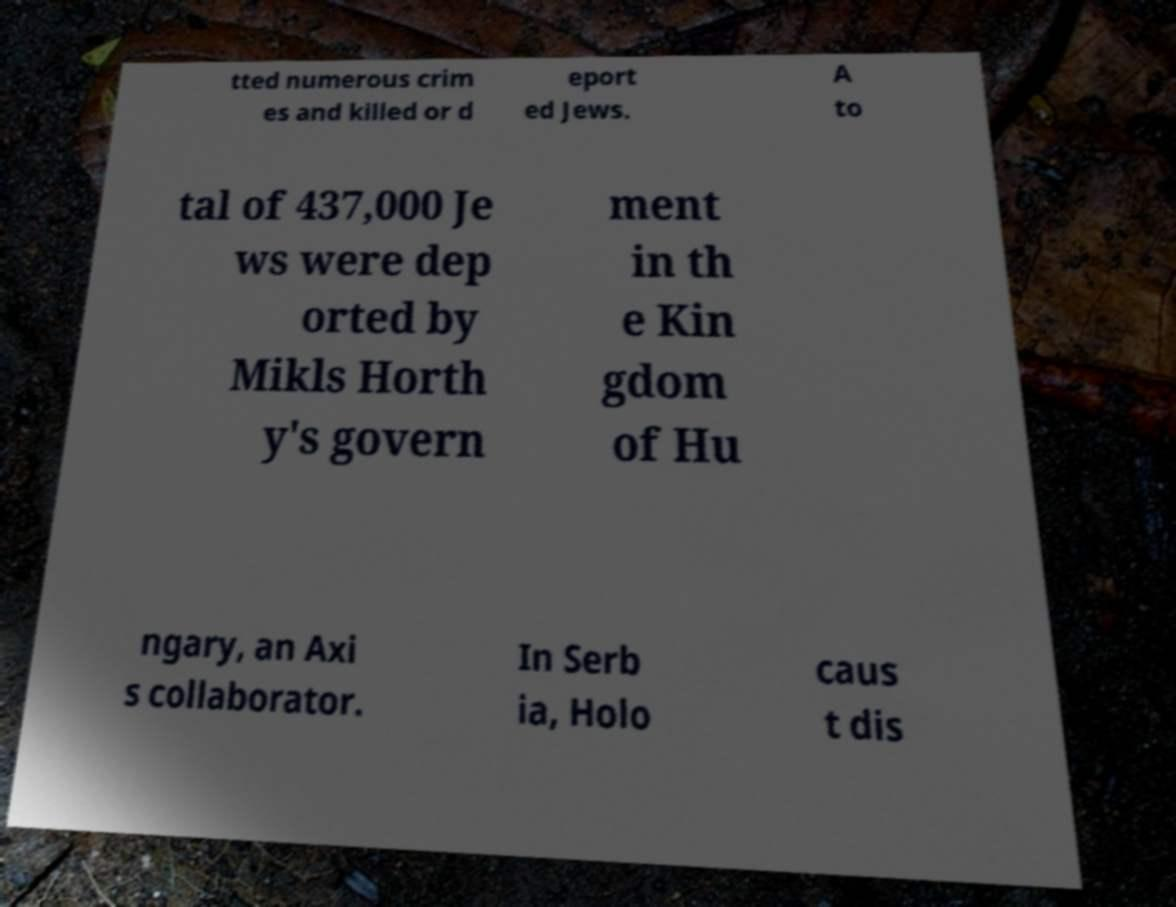What messages or text are displayed in this image? I need them in a readable, typed format. tted numerous crim es and killed or d eport ed Jews. A to tal of 437,000 Je ws were dep orted by Mikls Horth y's govern ment in th e Kin gdom of Hu ngary, an Axi s collaborator. In Serb ia, Holo caus t dis 